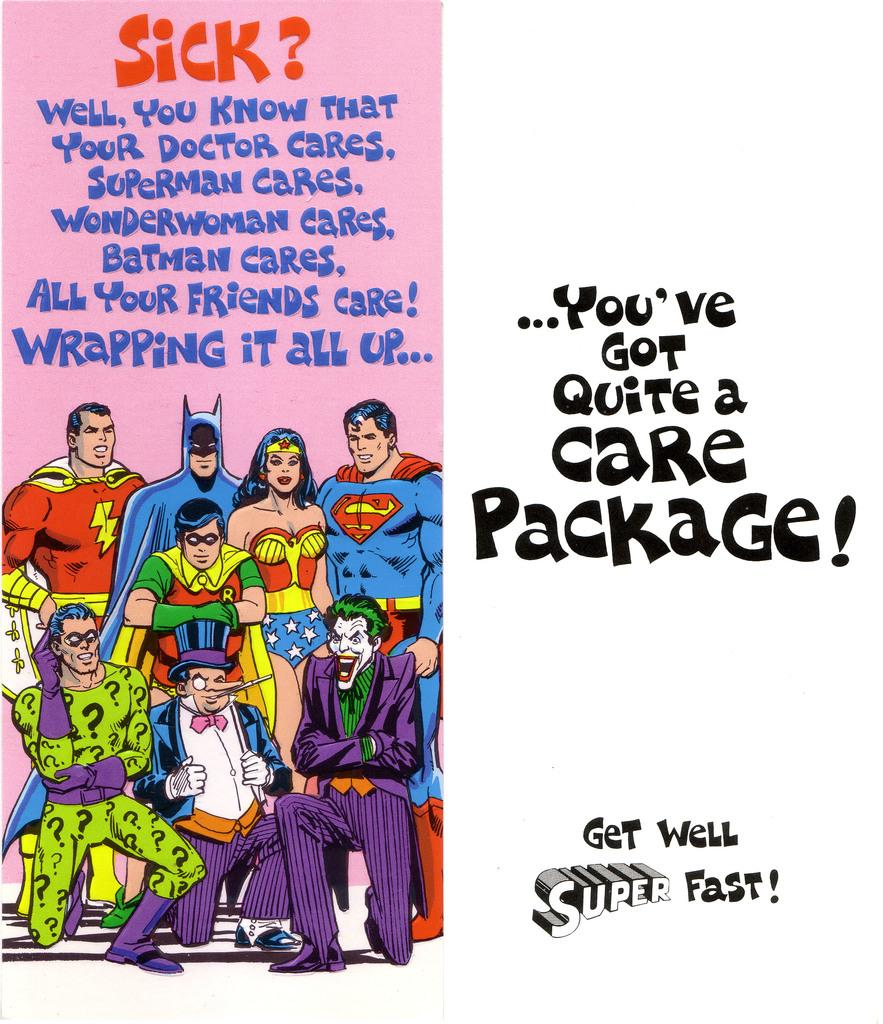What is present in the image that contains both text and pictures? There is a poster in the image that contains text and pictures of persons. Can you describe the text on the poster? The text on the poster is visible, but its content is not specified in the provided facts. What type of images are on the poster besides the pictures of persons? The provided facts do not mention any other images on the poster besides the pictures of persons. How many cats are depicted on the poster in the image? There is no mention of cats in the provided facts, so it cannot be determined if any cats are depicted on the poster. 